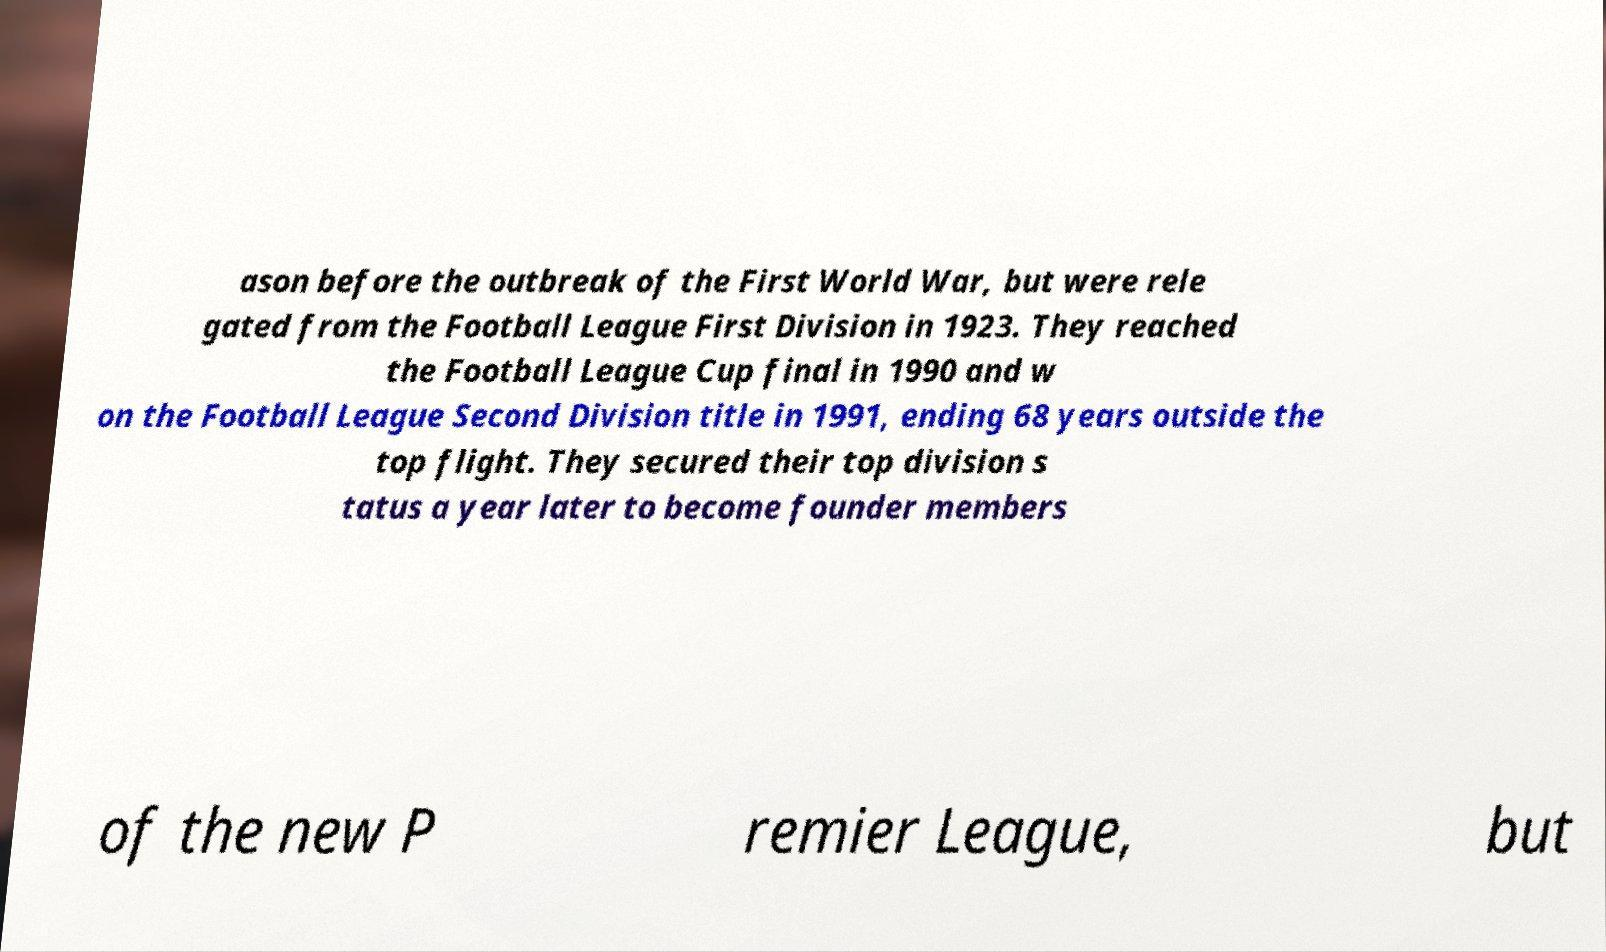Please read and relay the text visible in this image. What does it say? ason before the outbreak of the First World War, but were rele gated from the Football League First Division in 1923. They reached the Football League Cup final in 1990 and w on the Football League Second Division title in 1991, ending 68 years outside the top flight. They secured their top division s tatus a year later to become founder members of the new P remier League, but 